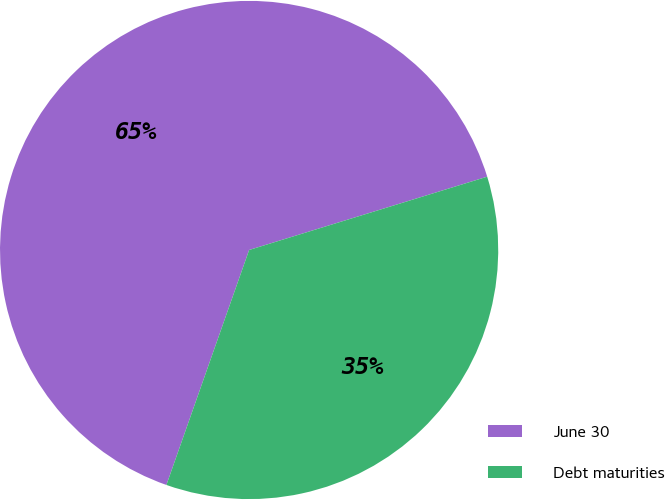<chart> <loc_0><loc_0><loc_500><loc_500><pie_chart><fcel>June 30<fcel>Debt maturities<nl><fcel>64.86%<fcel>35.14%<nl></chart> 